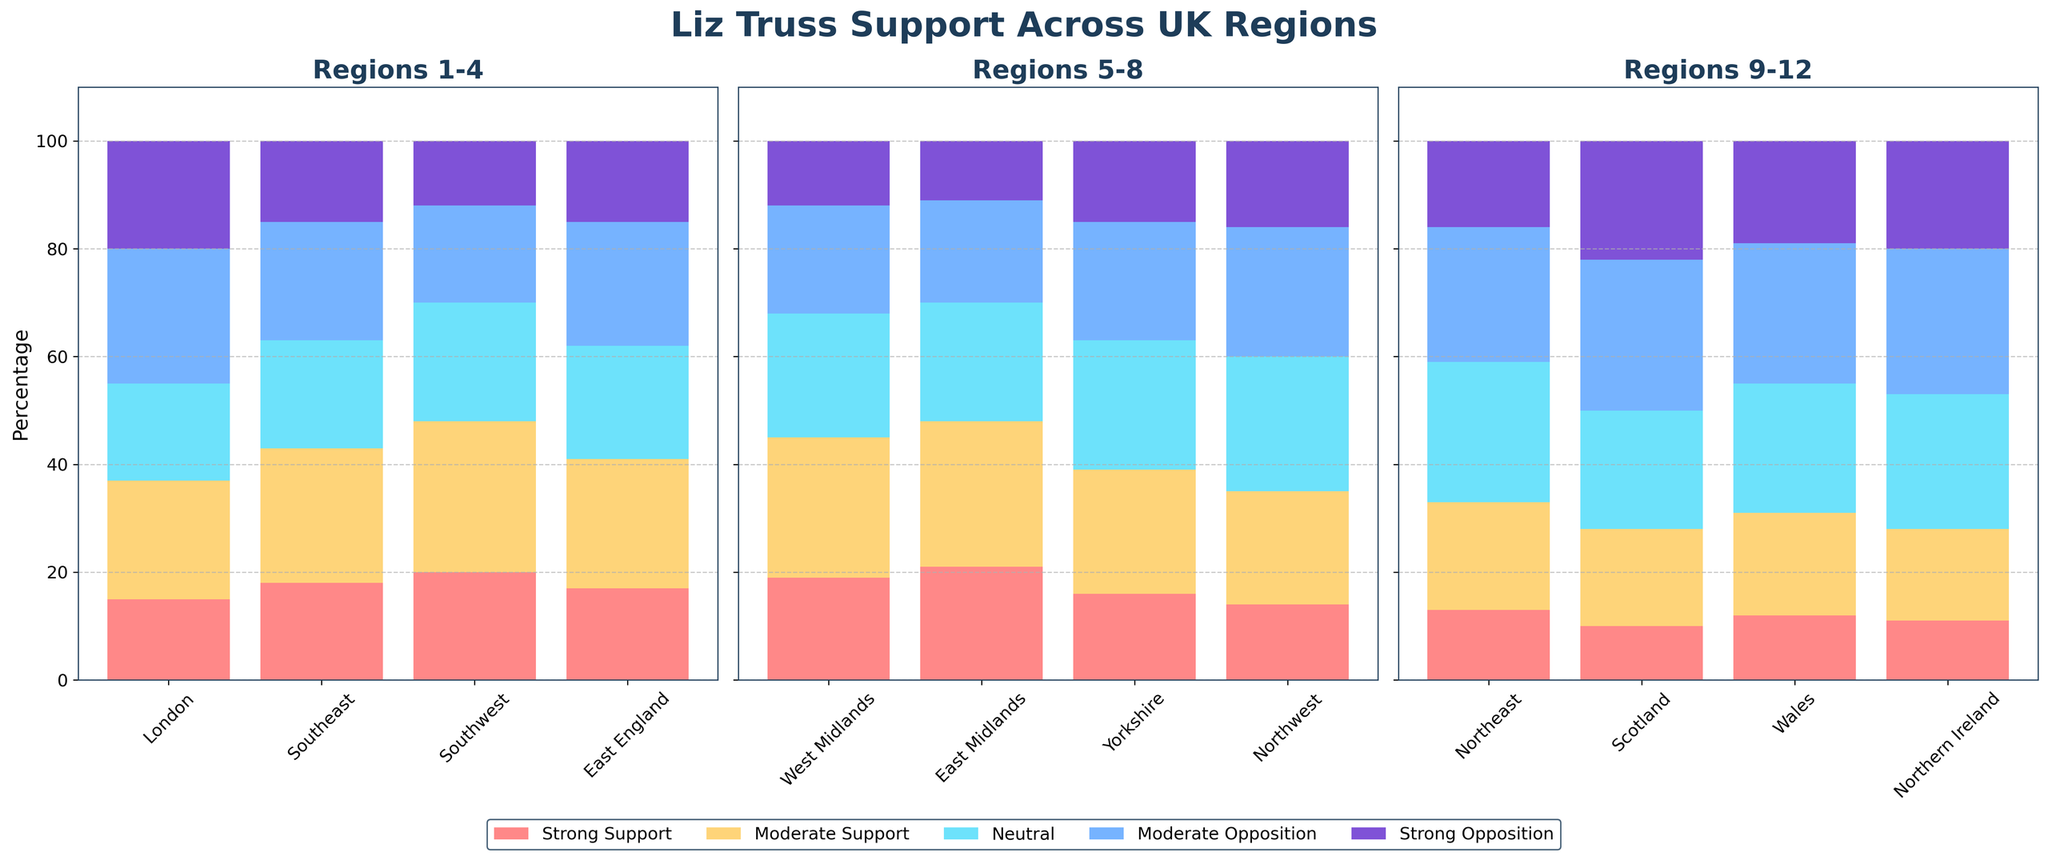Which region has the highest percentage of strong support for Liz Truss? By examining each subplot, the region with the tallest red bar indicates the highest percentage of strong support. The Southwest region has the highest percentage of strong support at 20%.
Answer: Southwest Which region has the highest percentage of strong opposition to Liz Truss? Identify the region with the tallest purple bar across all subplots. Scotland has the highest percentage of strong opposition at 22%.
Answer: Scotland What is the average percentage of moderate support across all regions? Add up the percentages of moderate support for all regions: 22 + 25 + 28 + 24 + 26 + 27 + 23 + 21 + 20 + 18 + 19 + 17 = 270. Then, divide by the number of regions: 270/12 = 22.5.
Answer: 22.5% In which regions is the percentage of neutral support greater than 20%? Check each subplot to see which regions have the blue neutral bar exceeding 20%. These regions are the West Midlands, East Midlands, Yorkshire, Northwest, Northeast, Wales, and Northern Ireland.
Answer: West Midlands, East Midlands, Yorkshire, Northwest, Northeast, Wales, Northern Ireland What is the combined percentage of strong and moderate opposition in Scotland? Add the strong opposition (22%) and moderate opposition (28%) for Scotland: 22 + 28 = 50%.
Answer: 50% Compare the percentage of strong support between London and the Southeast. Which one is higher? The strong support percentages are 15% for London and 18% for the Southeast. The Southeast has a higher strong support percentage.
Answer: Southeast In which region is the neutral support percentage the highest? Identify the region with the tallest blue bar across all subplots. The Northeast has the highest neutral support percentage at 26%.
Answer: Northeast What is the ratio of strong support to strong opposition in the Southeast? The percentages are 18% for strong support and 15% for strong opposition. The ratio is 18:15, which simplifies to 6:5.
Answer: 6:5 